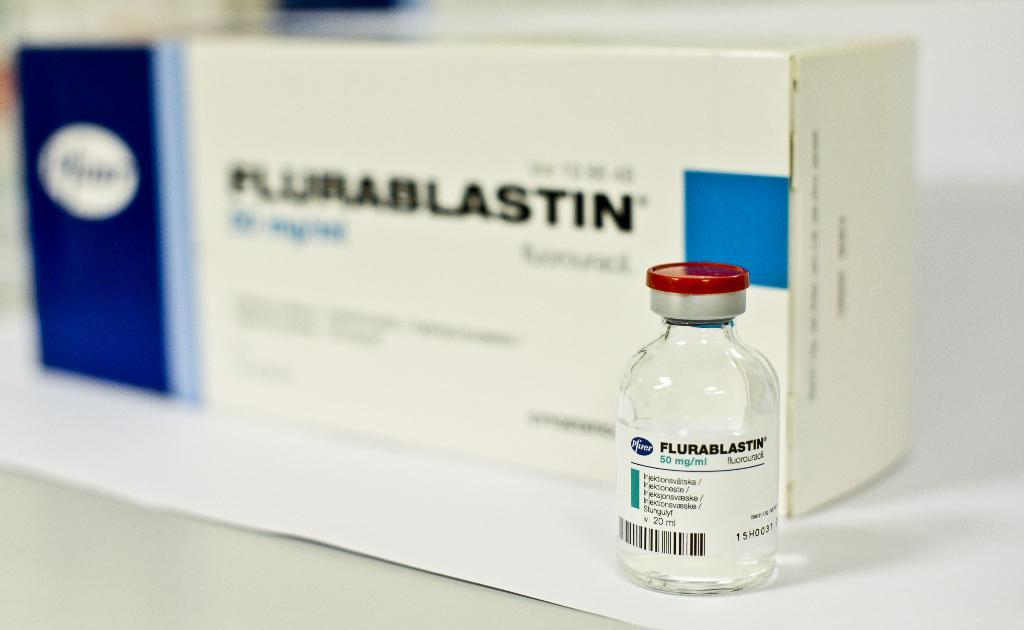<image>
Summarize the visual content of the image. Flurablastin medication of 50 mg, which says: Fluorouracil. 